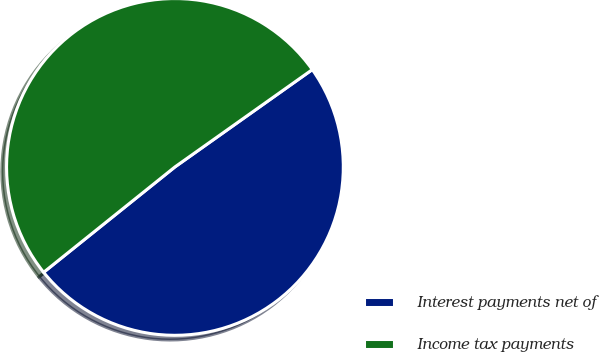<chart> <loc_0><loc_0><loc_500><loc_500><pie_chart><fcel>Interest payments net of<fcel>Income tax payments<nl><fcel>49.05%<fcel>50.95%<nl></chart> 